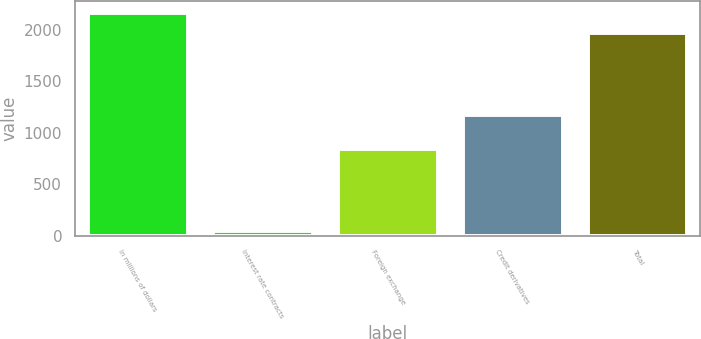Convert chart. <chart><loc_0><loc_0><loc_500><loc_500><bar_chart><fcel>In millions of dollars<fcel>Interest rate contracts<fcel>Foreign exchange<fcel>Credit derivatives<fcel>Total<nl><fcel>2166.5<fcel>51<fcel>847<fcel>1174<fcel>1970<nl></chart> 